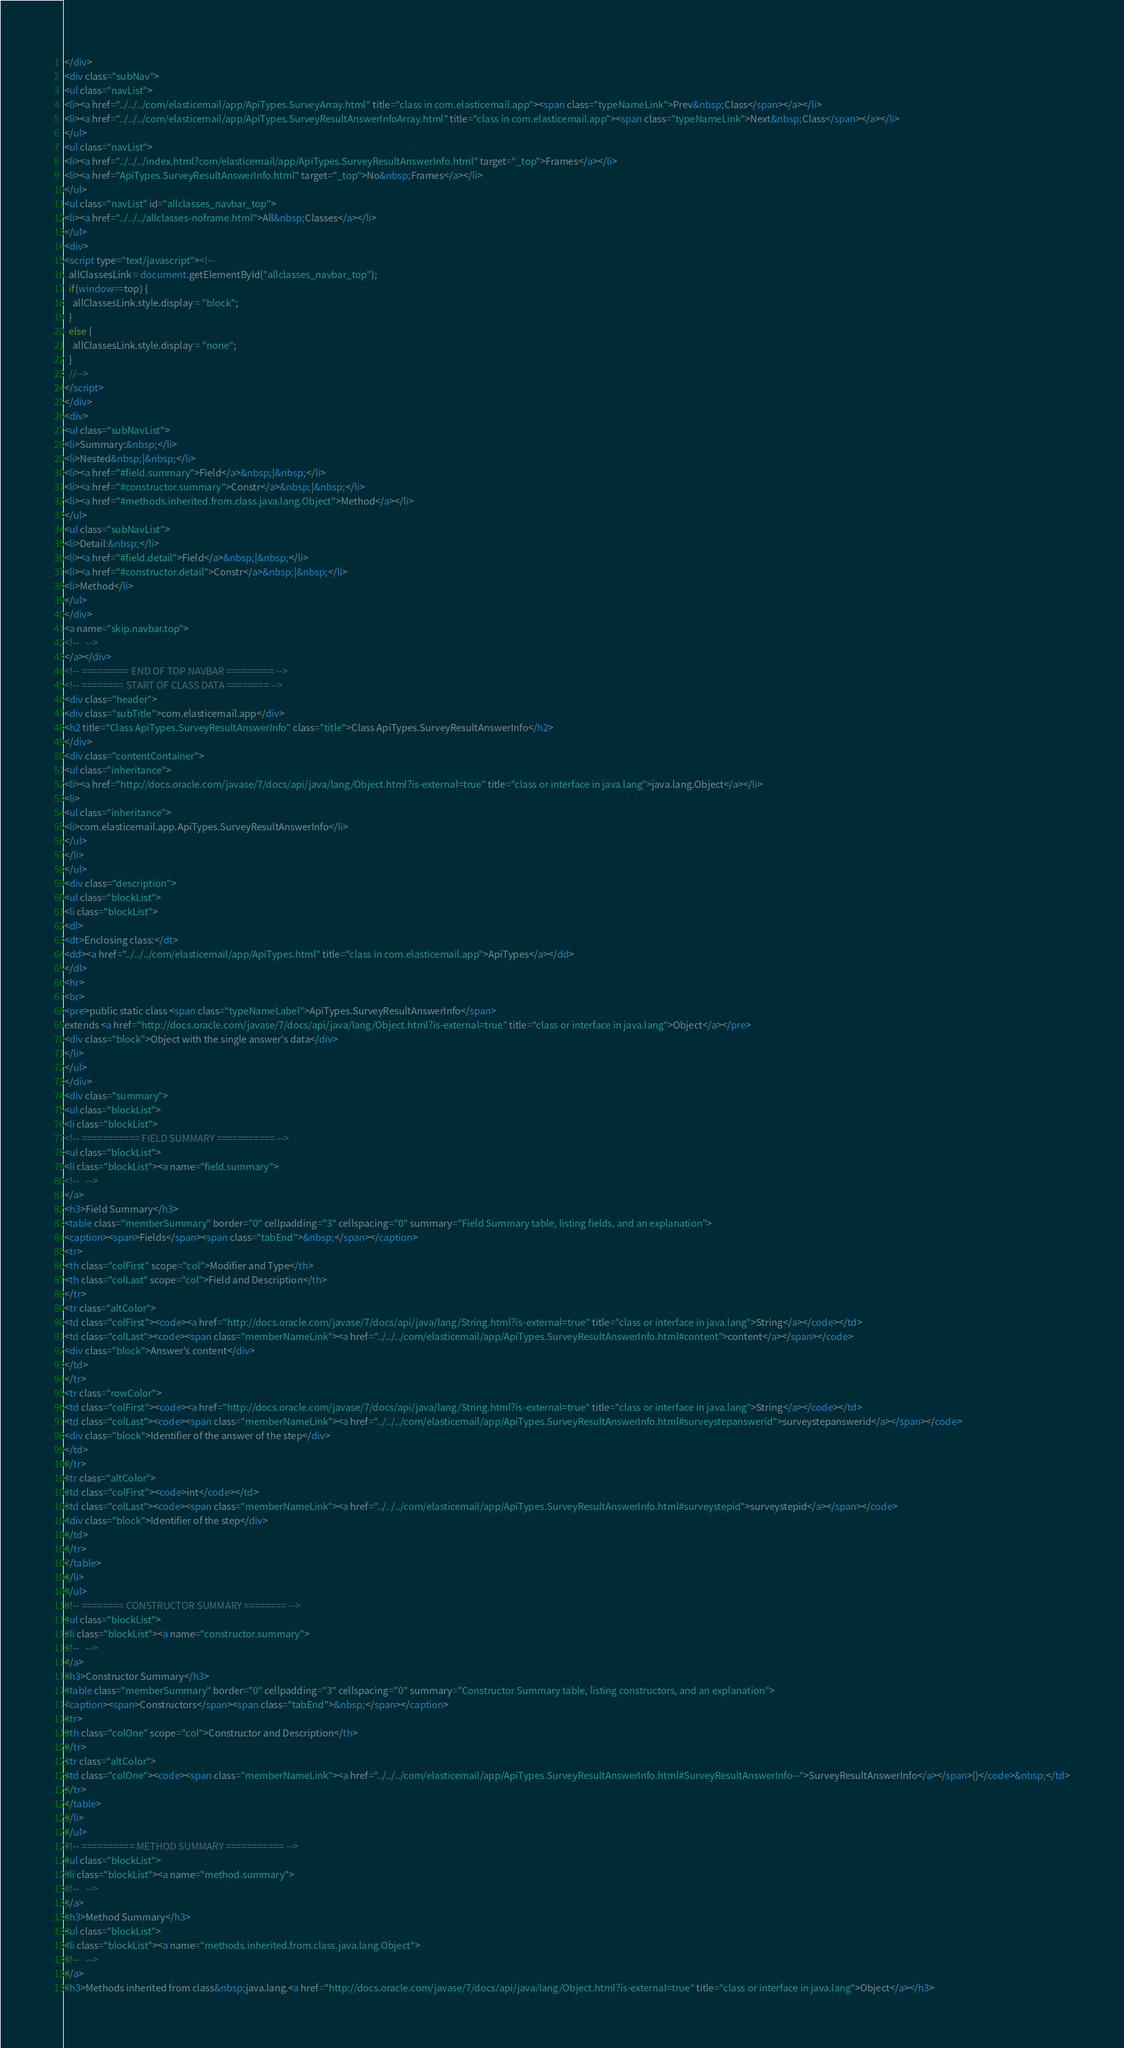Convert code to text. <code><loc_0><loc_0><loc_500><loc_500><_HTML_></div>
<div class="subNav">
<ul class="navList">
<li><a href="../../../com/elasticemail/app/ApiTypes.SurveyArray.html" title="class in com.elasticemail.app"><span class="typeNameLink">Prev&nbsp;Class</span></a></li>
<li><a href="../../../com/elasticemail/app/ApiTypes.SurveyResultAnswerInfoArray.html" title="class in com.elasticemail.app"><span class="typeNameLink">Next&nbsp;Class</span></a></li>
</ul>
<ul class="navList">
<li><a href="../../../index.html?com/elasticemail/app/ApiTypes.SurveyResultAnswerInfo.html" target="_top">Frames</a></li>
<li><a href="ApiTypes.SurveyResultAnswerInfo.html" target="_top">No&nbsp;Frames</a></li>
</ul>
<ul class="navList" id="allclasses_navbar_top">
<li><a href="../../../allclasses-noframe.html">All&nbsp;Classes</a></li>
</ul>
<div>
<script type="text/javascript"><!--
  allClassesLink = document.getElementById("allclasses_navbar_top");
  if(window==top) {
    allClassesLink.style.display = "block";
  }
  else {
    allClassesLink.style.display = "none";
  }
  //-->
</script>
</div>
<div>
<ul class="subNavList">
<li>Summary:&nbsp;</li>
<li>Nested&nbsp;|&nbsp;</li>
<li><a href="#field.summary">Field</a>&nbsp;|&nbsp;</li>
<li><a href="#constructor.summary">Constr</a>&nbsp;|&nbsp;</li>
<li><a href="#methods.inherited.from.class.java.lang.Object">Method</a></li>
</ul>
<ul class="subNavList">
<li>Detail:&nbsp;</li>
<li><a href="#field.detail">Field</a>&nbsp;|&nbsp;</li>
<li><a href="#constructor.detail">Constr</a>&nbsp;|&nbsp;</li>
<li>Method</li>
</ul>
</div>
<a name="skip.navbar.top">
<!--   -->
</a></div>
<!-- ========= END OF TOP NAVBAR ========= -->
<!-- ======== START OF CLASS DATA ======== -->
<div class="header">
<div class="subTitle">com.elasticemail.app</div>
<h2 title="Class ApiTypes.SurveyResultAnswerInfo" class="title">Class ApiTypes.SurveyResultAnswerInfo</h2>
</div>
<div class="contentContainer">
<ul class="inheritance">
<li><a href="http://docs.oracle.com/javase/7/docs/api/java/lang/Object.html?is-external=true" title="class or interface in java.lang">java.lang.Object</a></li>
<li>
<ul class="inheritance">
<li>com.elasticemail.app.ApiTypes.SurveyResultAnswerInfo</li>
</ul>
</li>
</ul>
<div class="description">
<ul class="blockList">
<li class="blockList">
<dl>
<dt>Enclosing class:</dt>
<dd><a href="../../../com/elasticemail/app/ApiTypes.html" title="class in com.elasticemail.app">ApiTypes</a></dd>
</dl>
<hr>
<br>
<pre>public static class <span class="typeNameLabel">ApiTypes.SurveyResultAnswerInfo</span>
extends <a href="http://docs.oracle.com/javase/7/docs/api/java/lang/Object.html?is-external=true" title="class or interface in java.lang">Object</a></pre>
<div class="block">Object with the single answer's data</div>
</li>
</ul>
</div>
<div class="summary">
<ul class="blockList">
<li class="blockList">
<!-- =========== FIELD SUMMARY =========== -->
<ul class="blockList">
<li class="blockList"><a name="field.summary">
<!--   -->
</a>
<h3>Field Summary</h3>
<table class="memberSummary" border="0" cellpadding="3" cellspacing="0" summary="Field Summary table, listing fields, and an explanation">
<caption><span>Fields</span><span class="tabEnd">&nbsp;</span></caption>
<tr>
<th class="colFirst" scope="col">Modifier and Type</th>
<th class="colLast" scope="col">Field and Description</th>
</tr>
<tr class="altColor">
<td class="colFirst"><code><a href="http://docs.oracle.com/javase/7/docs/api/java/lang/String.html?is-external=true" title="class or interface in java.lang">String</a></code></td>
<td class="colLast"><code><span class="memberNameLink"><a href="../../../com/elasticemail/app/ApiTypes.SurveyResultAnswerInfo.html#content">content</a></span></code>
<div class="block">Answer's content</div>
</td>
</tr>
<tr class="rowColor">
<td class="colFirst"><code><a href="http://docs.oracle.com/javase/7/docs/api/java/lang/String.html?is-external=true" title="class or interface in java.lang">String</a></code></td>
<td class="colLast"><code><span class="memberNameLink"><a href="../../../com/elasticemail/app/ApiTypes.SurveyResultAnswerInfo.html#surveystepanswerid">surveystepanswerid</a></span></code>
<div class="block">Identifier of the answer of the step</div>
</td>
</tr>
<tr class="altColor">
<td class="colFirst"><code>int</code></td>
<td class="colLast"><code><span class="memberNameLink"><a href="../../../com/elasticemail/app/ApiTypes.SurveyResultAnswerInfo.html#surveystepid">surveystepid</a></span></code>
<div class="block">Identifier of the step</div>
</td>
</tr>
</table>
</li>
</ul>
<!-- ======== CONSTRUCTOR SUMMARY ======== -->
<ul class="blockList">
<li class="blockList"><a name="constructor.summary">
<!--   -->
</a>
<h3>Constructor Summary</h3>
<table class="memberSummary" border="0" cellpadding="3" cellspacing="0" summary="Constructor Summary table, listing constructors, and an explanation">
<caption><span>Constructors</span><span class="tabEnd">&nbsp;</span></caption>
<tr>
<th class="colOne" scope="col">Constructor and Description</th>
</tr>
<tr class="altColor">
<td class="colOne"><code><span class="memberNameLink"><a href="../../../com/elasticemail/app/ApiTypes.SurveyResultAnswerInfo.html#SurveyResultAnswerInfo--">SurveyResultAnswerInfo</a></span>()</code>&nbsp;</td>
</tr>
</table>
</li>
</ul>
<!-- ========== METHOD SUMMARY =========== -->
<ul class="blockList">
<li class="blockList"><a name="method.summary">
<!--   -->
</a>
<h3>Method Summary</h3>
<ul class="blockList">
<li class="blockList"><a name="methods.inherited.from.class.java.lang.Object">
<!--   -->
</a>
<h3>Methods inherited from class&nbsp;java.lang.<a href="http://docs.oracle.com/javase/7/docs/api/java/lang/Object.html?is-external=true" title="class or interface in java.lang">Object</a></h3></code> 